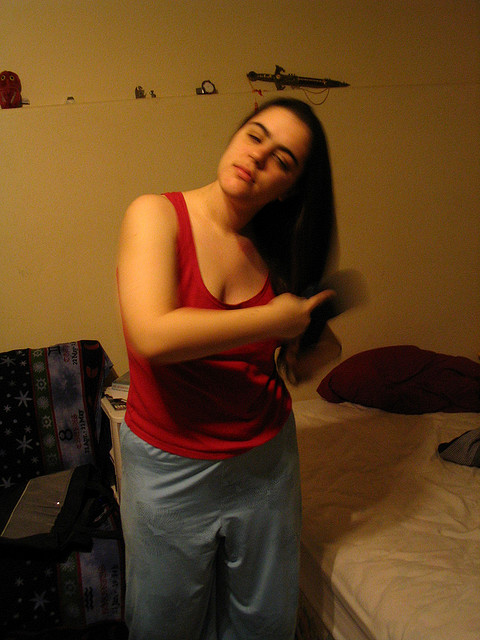<image>What animal is in the picture? There is no animal in the picture. However, there might be a human. What color is the instrument in the background? There is no instrument seen in the background. However, it may be black, silver or brown if present. What animal is in the picture? I don't know what animal is in the picture. It can be seen both human and no animal. What color is the instrument in the background? I don't know what color is the instrument in the background. It can be black, silver or brown. 